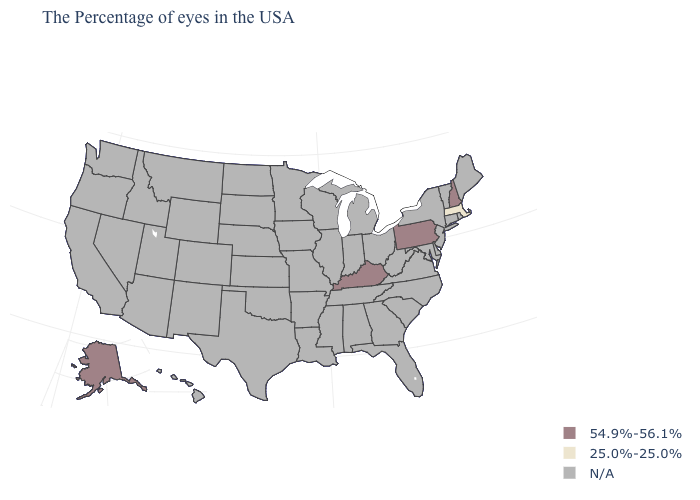What is the highest value in the Northeast ?
Keep it brief. 54.9%-56.1%. What is the value of South Dakota?
Be succinct. N/A. Name the states that have a value in the range 54.9%-56.1%?
Keep it brief. New Hampshire, Pennsylvania, Kentucky, Alaska. What is the lowest value in the USA?
Give a very brief answer. 25.0%-25.0%. Which states have the lowest value in the USA?
Give a very brief answer. Massachusetts. What is the highest value in the USA?
Keep it brief. 54.9%-56.1%. Name the states that have a value in the range 25.0%-25.0%?
Write a very short answer. Massachusetts. Which states hav the highest value in the West?
Answer briefly. Alaska. What is the highest value in the Northeast ?
Be succinct. 54.9%-56.1%. Does the first symbol in the legend represent the smallest category?
Be succinct. No. What is the value of North Dakota?
Short answer required. N/A. 